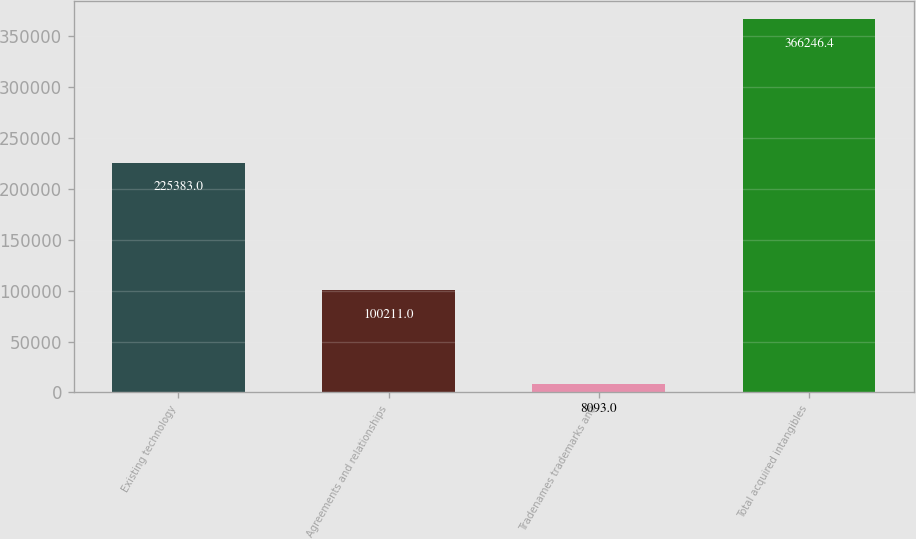Convert chart. <chart><loc_0><loc_0><loc_500><loc_500><bar_chart><fcel>Existing technology<fcel>Agreements and relationships<fcel>Tradenames trademarks and<fcel>Total acquired intangibles<nl><fcel>225383<fcel>100211<fcel>8093<fcel>366246<nl></chart> 